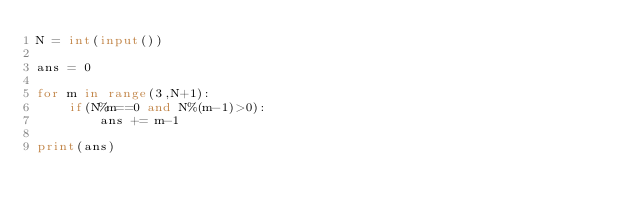Convert code to text. <code><loc_0><loc_0><loc_500><loc_500><_Python_>N = int(input())

ans = 0

for m in range(3,N+1):
    if(N%m==0 and N%(m-1)>0):
        ans += m-1

print(ans)</code> 